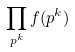<formula> <loc_0><loc_0><loc_500><loc_500>\prod _ { p ^ { k } } f ( p ^ { k } )</formula> 